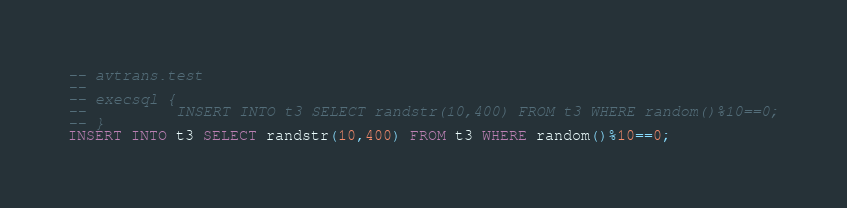Convert code to text. <code><loc_0><loc_0><loc_500><loc_500><_SQL_>-- avtrans.test
-- 
-- execsql {
--          INSERT INTO t3 SELECT randstr(10,400) FROM t3 WHERE random()%10==0;
-- }
INSERT INTO t3 SELECT randstr(10,400) FROM t3 WHERE random()%10==0;</code> 